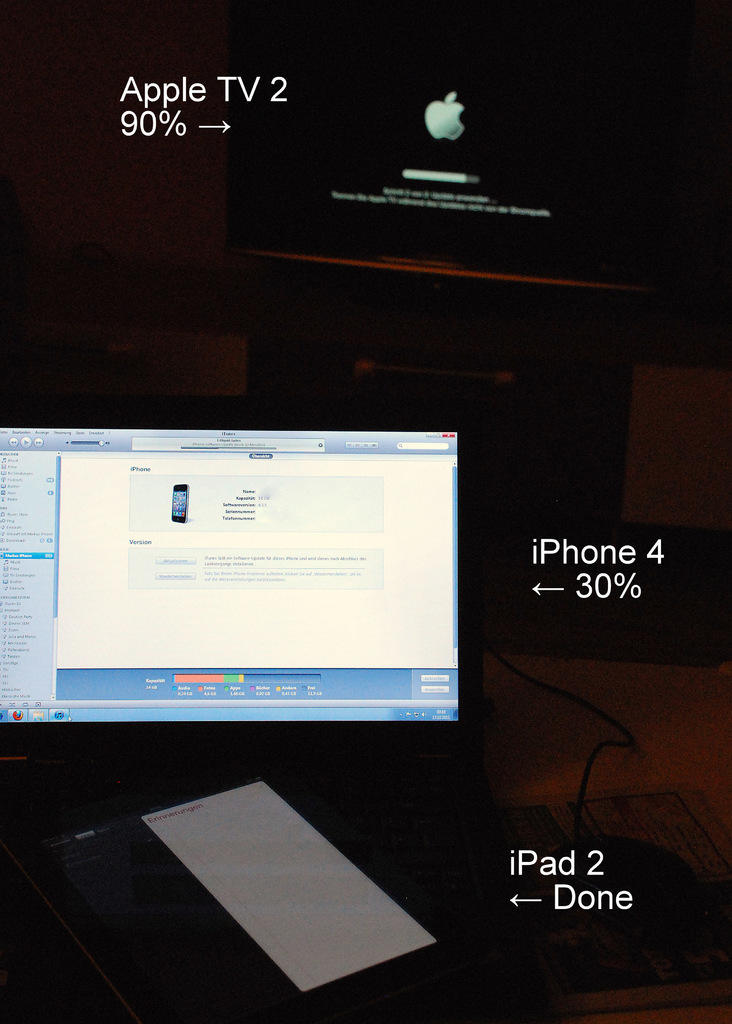What different activities are possibly going on with these devices in this image? This image depicts multiple Apple devices likely undergoing synchronization or updates. The Apple TV shows a progress bar indicating an update, whereas the iPhone 4's screen suggests a settings adjustment or update progress, and the iPad 2 seems to have completed a task, since it's labeled 'Done'. 